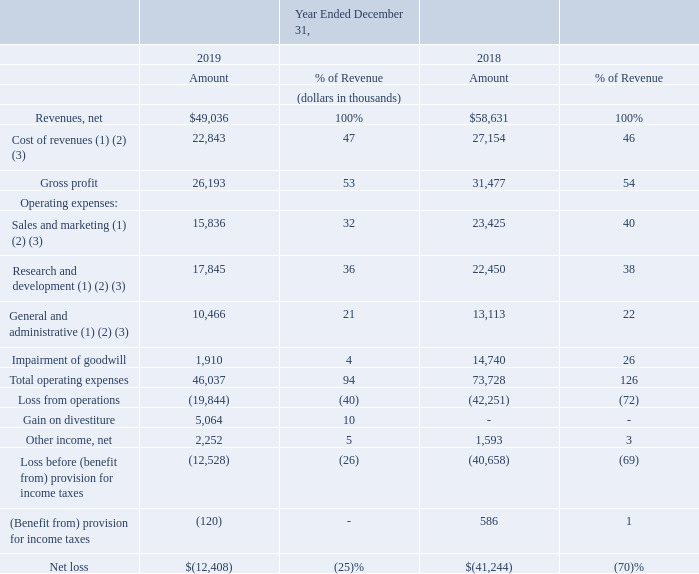Results of Operations
The following table is a summary of our consolidated statements of operations for the specified periods and results of operations as a percentage of revenues for those periods. The period-to-period comparisons of results are not necessarily indicative of results for future periods. Percentage of revenues figures are rounded and therefore may not subtotal exactly.
A discussion regarding our consolidated statements of operations and results of operations as a percentage of revenue for 2019 compared to 2018 is presented below. A discussion regarding our financial condition and results of operations for 2018 compared to 2017 can be found under Item 7 in our Annual Report on Form 10-K for the fiscal year ended December 31, 2018, filed with the SEC on March 14, 2019, which is available free of charge on the SEC’s website at www.sec.go.
(1)  Stock-based compensation expense included in the consolidated statements of operations data above was as follows:
(2)  Amortization of intangible assets included in the consolidated statements of operations data above was as follows:
(3) Restructuring-related expenses included in the consolidated statements of operations data above was as follows:
What are the company's respective net revenue from operations in 2018 and 2019?
Answer scale should be: thousand. $58,631, $49,036. What are the company's respective cost of revenue from operations in 2018 and 2019?
Answer scale should be: thousand. 27,154, 22,843. What are the company's respective gross profit from operations in 2018 and 2019?
Answer scale should be: thousand. 31,477, 26,193. What is the company's average net revenue from its operations in 2018 and 2019?
Answer scale should be: thousand. (58,631 + 49,036)/2
Answer: 53833.5. What is the company's percentage change in its net revenue from operations between 2018 and 2019?
Answer scale should be: percent. (49,036 - 58,631)/58,631 
Answer: -16.37. What is the company's percentage change in its gross profit from operations between 2018 and 2019?
Answer scale should be: percent. (26,193 - 31,477)/31,477 
Answer: -16.79. 